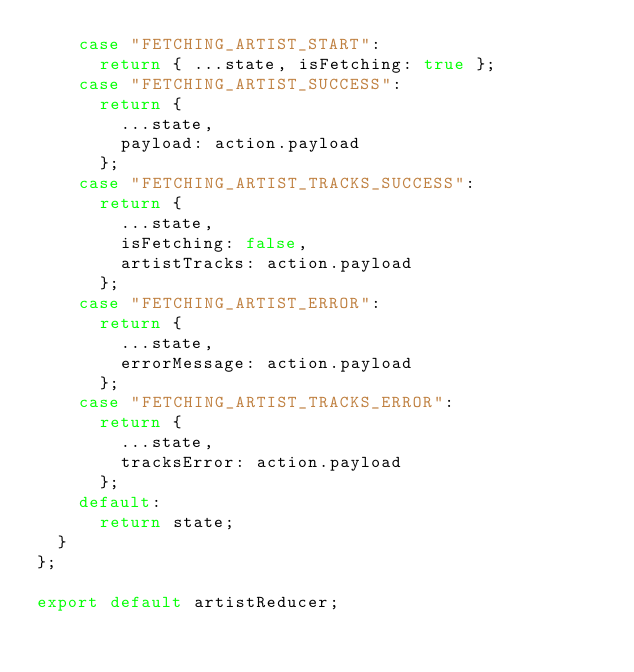Convert code to text. <code><loc_0><loc_0><loc_500><loc_500><_JavaScript_>    case "FETCHING_ARTIST_START":
      return { ...state, isFetching: true };
    case "FETCHING_ARTIST_SUCCESS":
      return {
        ...state,
        payload: action.payload
      };
    case "FETCHING_ARTIST_TRACKS_SUCCESS":
      return {
        ...state,
        isFetching: false,
        artistTracks: action.payload
      };
    case "FETCHING_ARTIST_ERROR":
      return {
        ...state,
        errorMessage: action.payload
      };
    case "FETCHING_ARTIST_TRACKS_ERROR":
      return {
        ...state,
        tracksError: action.payload
      };
    default:
      return state;
  }
};

export default artistReducer;
</code> 